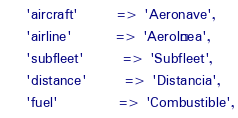<code> <loc_0><loc_0><loc_500><loc_500><_PHP_>    'aircraft'       => 'Aeronave',
    'airline'        => 'Aerolínea',
    'subfleet'       => 'Subfleet',
    'distance'       => 'Distancia',
    'fuel'           => 'Combustible',</code> 